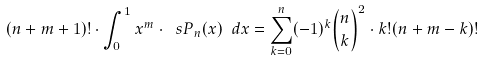Convert formula to latex. <formula><loc_0><loc_0><loc_500><loc_500>( n + m + 1 ) ! \cdot \int _ { 0 } ^ { 1 } x ^ { m } \cdot \ s P _ { n } ( x ) \ d x = \sum _ { k = 0 } ^ { n } ( - 1 ) ^ { k } \binom { n } { k } ^ { 2 } \cdot k ! ( n + m - k ) !</formula> 